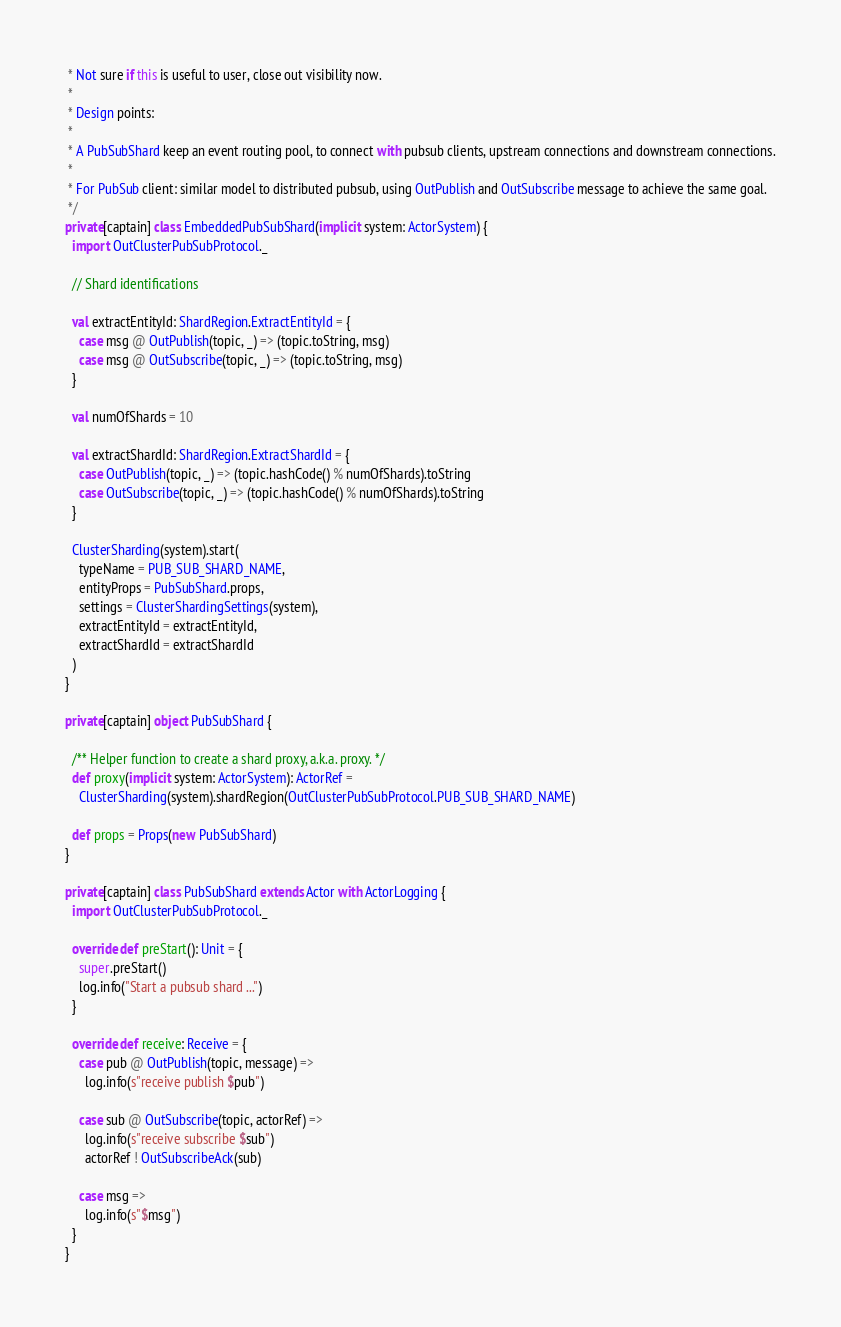<code> <loc_0><loc_0><loc_500><loc_500><_Scala_> * Not sure if this is useful to user, close out visibility now.
 *
 * Design points:
 *
 * A PubSubShard keep an event routing pool, to connect with pubsub clients, upstream connections and downstream connections.
 *
 * For PubSub client: similar model to distributed pubsub, using OutPublish and OutSubscribe message to achieve the same goal.
 */
private[captain] class EmbeddedPubSubShard(implicit system: ActorSystem) {
  import OutClusterPubSubProtocol._

  // Shard identifications

  val extractEntityId: ShardRegion.ExtractEntityId = {
    case msg @ OutPublish(topic, _) => (topic.toString, msg)
    case msg @ OutSubscribe(topic, _) => (topic.toString, msg)
  }

  val numOfShards = 10

  val extractShardId: ShardRegion.ExtractShardId = {
    case OutPublish(topic, _) => (topic.hashCode() % numOfShards).toString
    case OutSubscribe(topic, _) => (topic.hashCode() % numOfShards).toString
  }

  ClusterSharding(system).start(
    typeName = PUB_SUB_SHARD_NAME,
    entityProps = PubSubShard.props,
    settings = ClusterShardingSettings(system),
    extractEntityId = extractEntityId,
    extractShardId = extractShardId
  )
}

private[captain] object PubSubShard {

  /** Helper function to create a shard proxy, a.k.a. proxy. */
  def proxy(implicit system: ActorSystem): ActorRef =
    ClusterSharding(system).shardRegion(OutClusterPubSubProtocol.PUB_SUB_SHARD_NAME)

  def props = Props(new PubSubShard)
}

private[captain] class PubSubShard extends Actor with ActorLogging {
  import OutClusterPubSubProtocol._

  override def preStart(): Unit = {
    super.preStart()
    log.info("Start a pubsub shard ...")
  }

  override def receive: Receive = {
    case pub @ OutPublish(topic, message) =>
      log.info(s"receive publish $pub")

    case sub @ OutSubscribe(topic, actorRef) =>
      log.info(s"receive subscribe $sub")
      actorRef ! OutSubscribeAck(sub)

    case msg =>
      log.info(s"$msg")
  }
}
</code> 